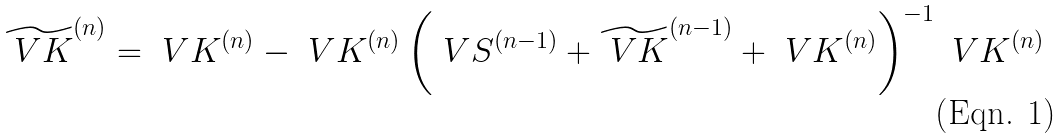<formula> <loc_0><loc_0><loc_500><loc_500>\widetilde { \ V { K } } ^ { ( n ) } = { \ V { K } } ^ { ( n ) } - { \ V { K } } ^ { ( n ) } \left ( { \ V { S } } ^ { ( n - 1 ) } + \widetilde { \ V { K } } ^ { ( n - 1 ) } + { \ V { K } } ^ { ( n ) } \right ) ^ { - 1 } { \ V { K } } ^ { ( n ) }</formula> 